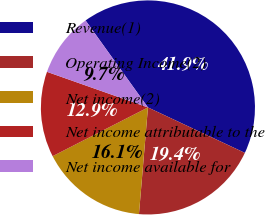Convert chart. <chart><loc_0><loc_0><loc_500><loc_500><pie_chart><fcel>Revenue(1)<fcel>Operating Income(2)<fcel>Net income(2)<fcel>Net income attributable to the<fcel>Net income available for<nl><fcel>41.88%<fcel>19.36%<fcel>16.14%<fcel>12.92%<fcel>9.7%<nl></chart> 